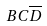<formula> <loc_0><loc_0><loc_500><loc_500>B C \overline { D }</formula> 